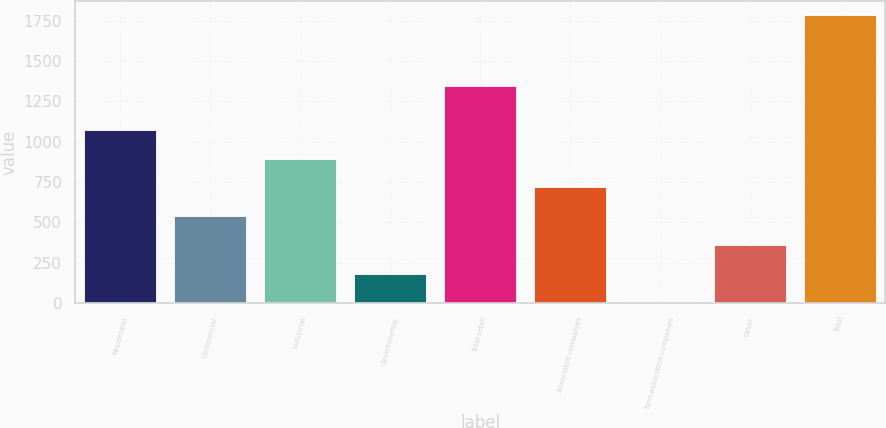Convert chart. <chart><loc_0><loc_0><loc_500><loc_500><bar_chart><fcel>Residential<fcel>Commercial<fcel>Industrial<fcel>Governmental<fcel>Total retail<fcel>Associated companies<fcel>Non-associated companies<fcel>Other<fcel>Total<nl><fcel>1072.2<fcel>539.1<fcel>894.5<fcel>183.7<fcel>1346<fcel>716.8<fcel>6<fcel>361.4<fcel>1783<nl></chart> 